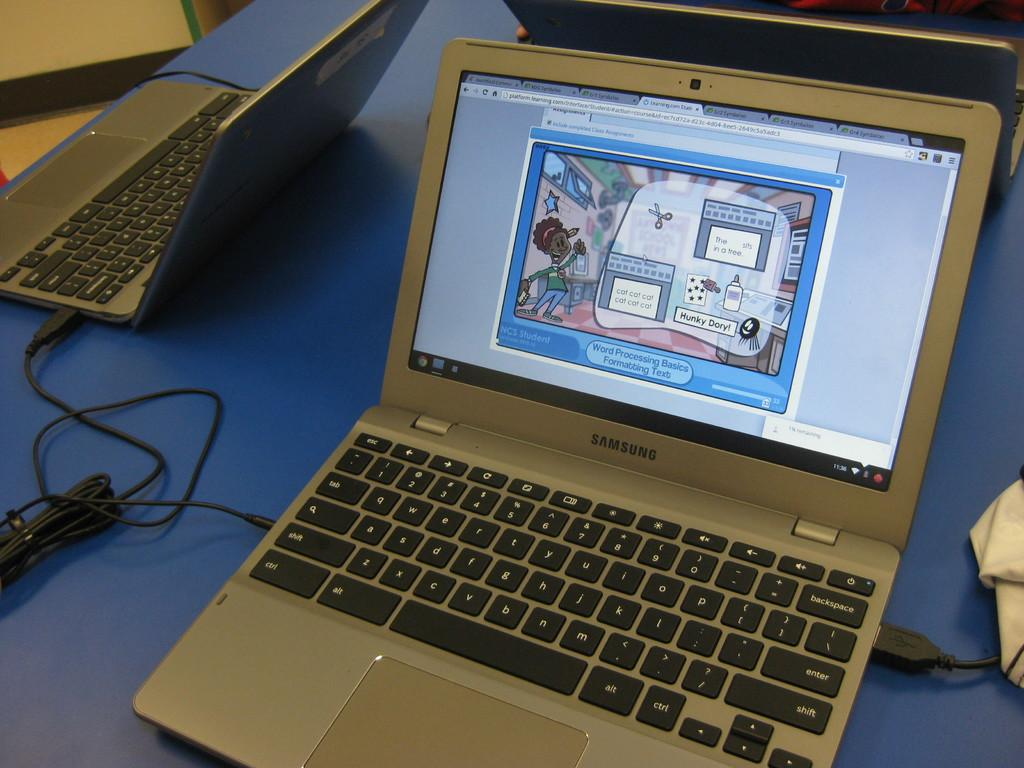What electronic devices are on the table in the image? There are laptops on the table in the image. What else can be seen on the table besides the laptops? There are cables and a cloth on the table. What is visible on the laptop screen? There is a picture visible on the laptop screen. Can you see any turkeys swimming in the ocean in the image? There is no reference to turkeys or an ocean in the image, so it is not possible to answer that question. 